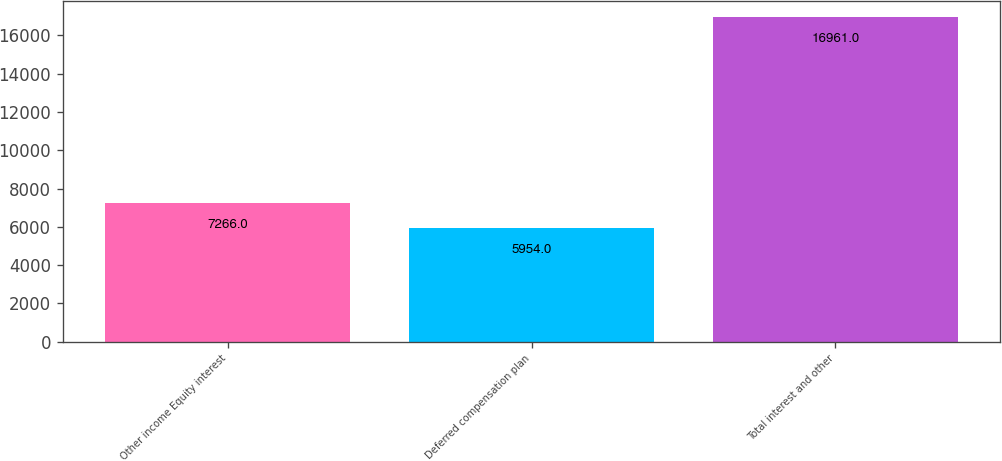<chart> <loc_0><loc_0><loc_500><loc_500><bar_chart><fcel>Other income Equity interest<fcel>Deferred compensation plan<fcel>Total interest and other<nl><fcel>7266<fcel>5954<fcel>16961<nl></chart> 